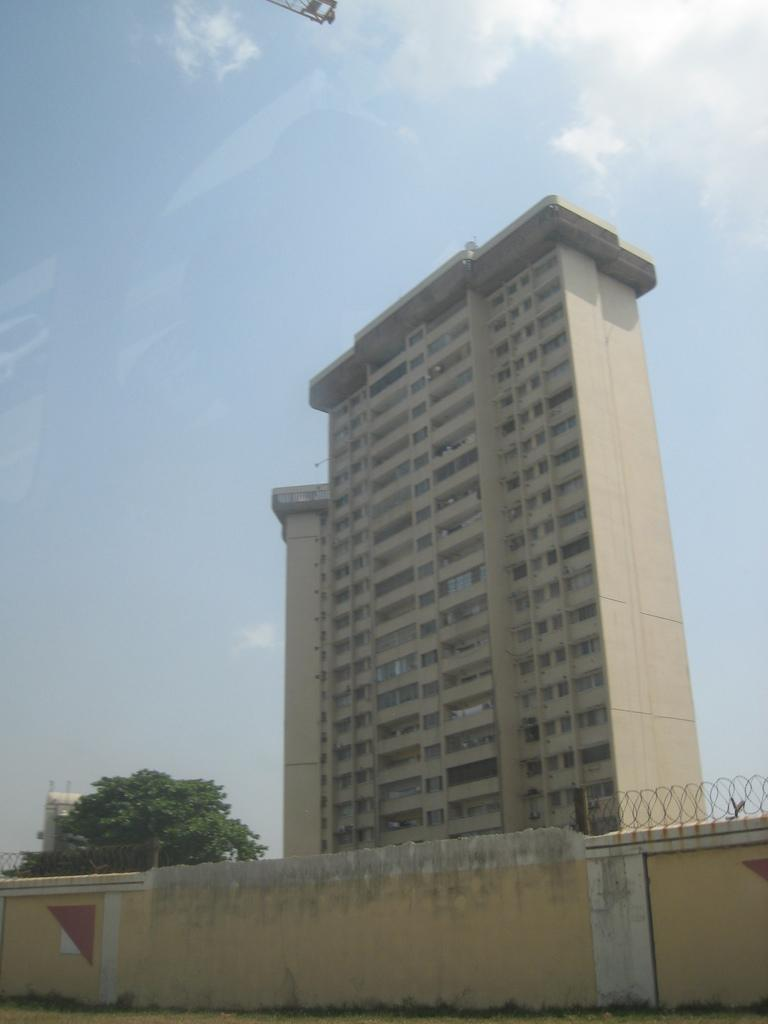What type of structure can be seen in the image? There is a wall in the image. What other structures are present in the image? There is a fence and buildings in the image. What type of vegetation is visible in the image? There is a tree in the image. What can be seen in the background of the image? The sky is visible in the background of the image. How many birds are sitting on the bed in the image? There is no bed present in the image, and therefore no birds can be seen sitting on it. 